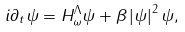<formula> <loc_0><loc_0><loc_500><loc_500>i \partial _ { t } \psi = H _ { \omega } ^ { \Lambda } \psi + \beta \left | \psi \right | ^ { 2 } \psi ,</formula> 